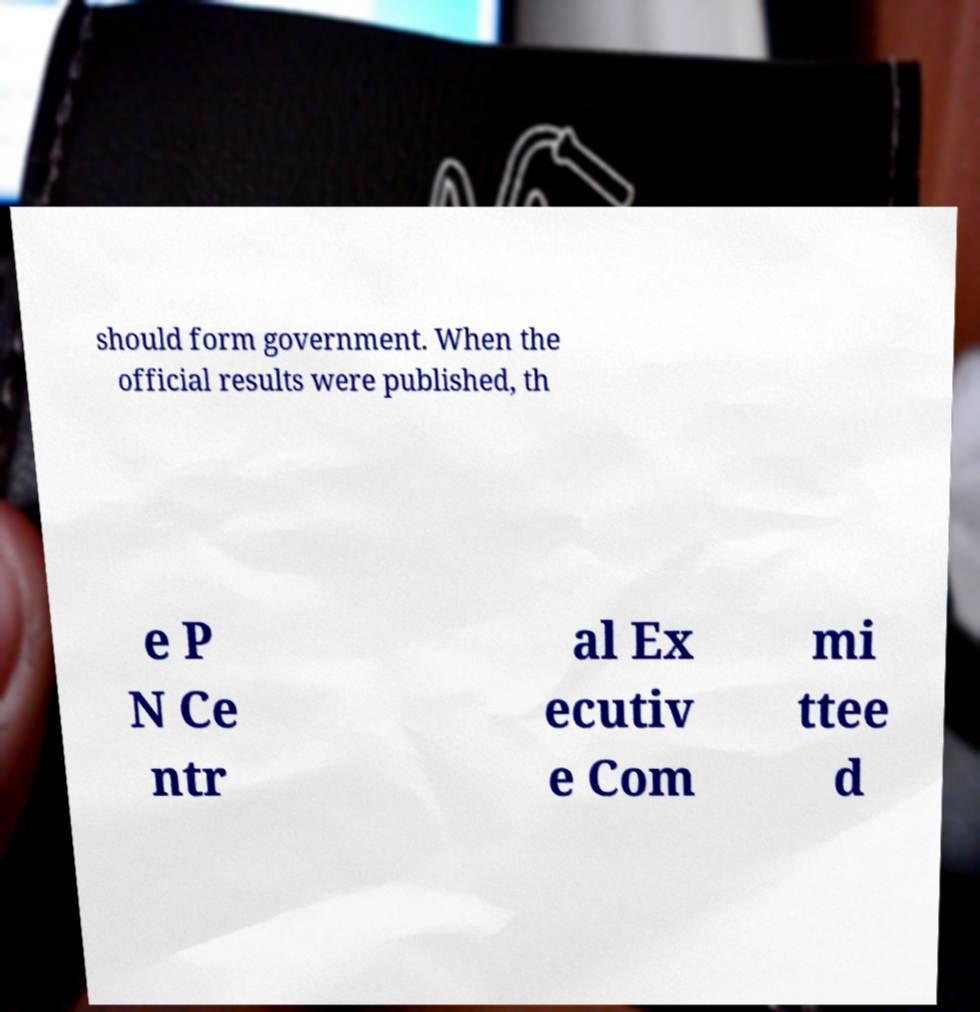I need the written content from this picture converted into text. Can you do that? should form government. When the official results were published, th e P N Ce ntr al Ex ecutiv e Com mi ttee d 